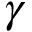<formula> <loc_0><loc_0><loc_500><loc_500>\gamma</formula> 